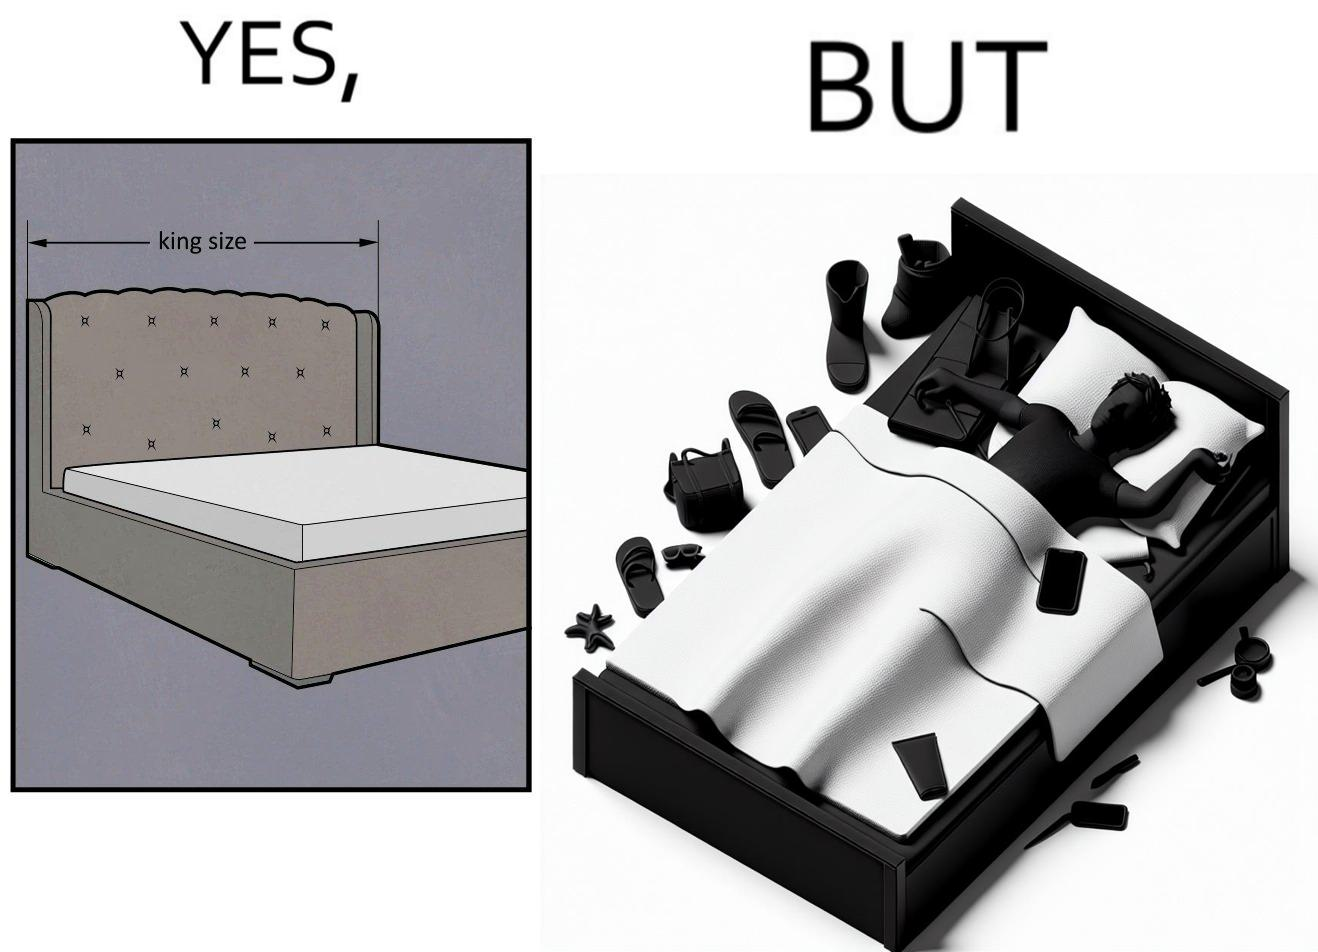Would you classify this image as satirical? Yes, this image is satirical. 